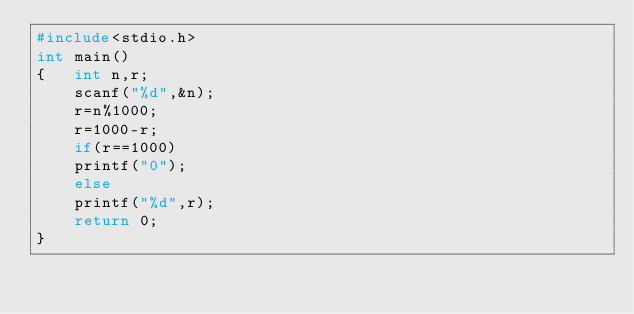Convert code to text. <code><loc_0><loc_0><loc_500><loc_500><_C_>#include<stdio.h>
int main()
{   int n,r;
    scanf("%d",&n);
    r=n%1000;
    r=1000-r;
    if(r==1000) 
    printf("0");
    else
    printf("%d",r);
    return 0;
}</code> 